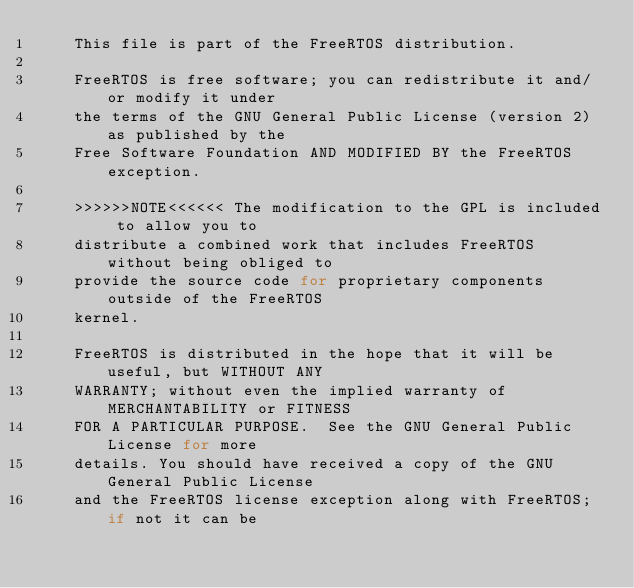Convert code to text. <code><loc_0><loc_0><loc_500><loc_500><_C_>    This file is part of the FreeRTOS distribution.

    FreeRTOS is free software; you can redistribute it and/or modify it under
    the terms of the GNU General Public License (version 2) as published by the
    Free Software Foundation AND MODIFIED BY the FreeRTOS exception.

    >>>>>>NOTE<<<<<< The modification to the GPL is included to allow you to
    distribute a combined work that includes FreeRTOS without being obliged to
    provide the source code for proprietary components outside of the FreeRTOS
    kernel.

    FreeRTOS is distributed in the hope that it will be useful, but WITHOUT ANY
    WARRANTY; without even the implied warranty of MERCHANTABILITY or FITNESS
    FOR A PARTICULAR PURPOSE.  See the GNU General Public License for more
    details. You should have received a copy of the GNU General Public License
    and the FreeRTOS license exception along with FreeRTOS; if not it can be</code> 